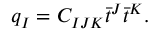<formula> <loc_0><loc_0><loc_500><loc_500>q _ { I } = C _ { I J K } \bar { t } ^ { J } \bar { t } ^ { K } .</formula> 